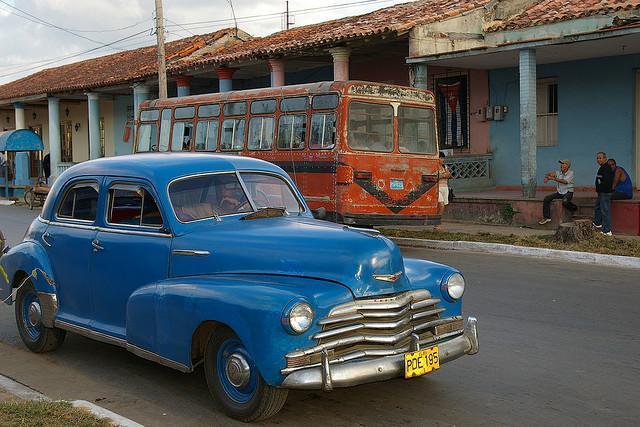How many red semis in the picture?
Give a very brief answer. 0. How many motorcycles are between the sidewalk and the yellow line in the road?
Give a very brief answer. 0. 